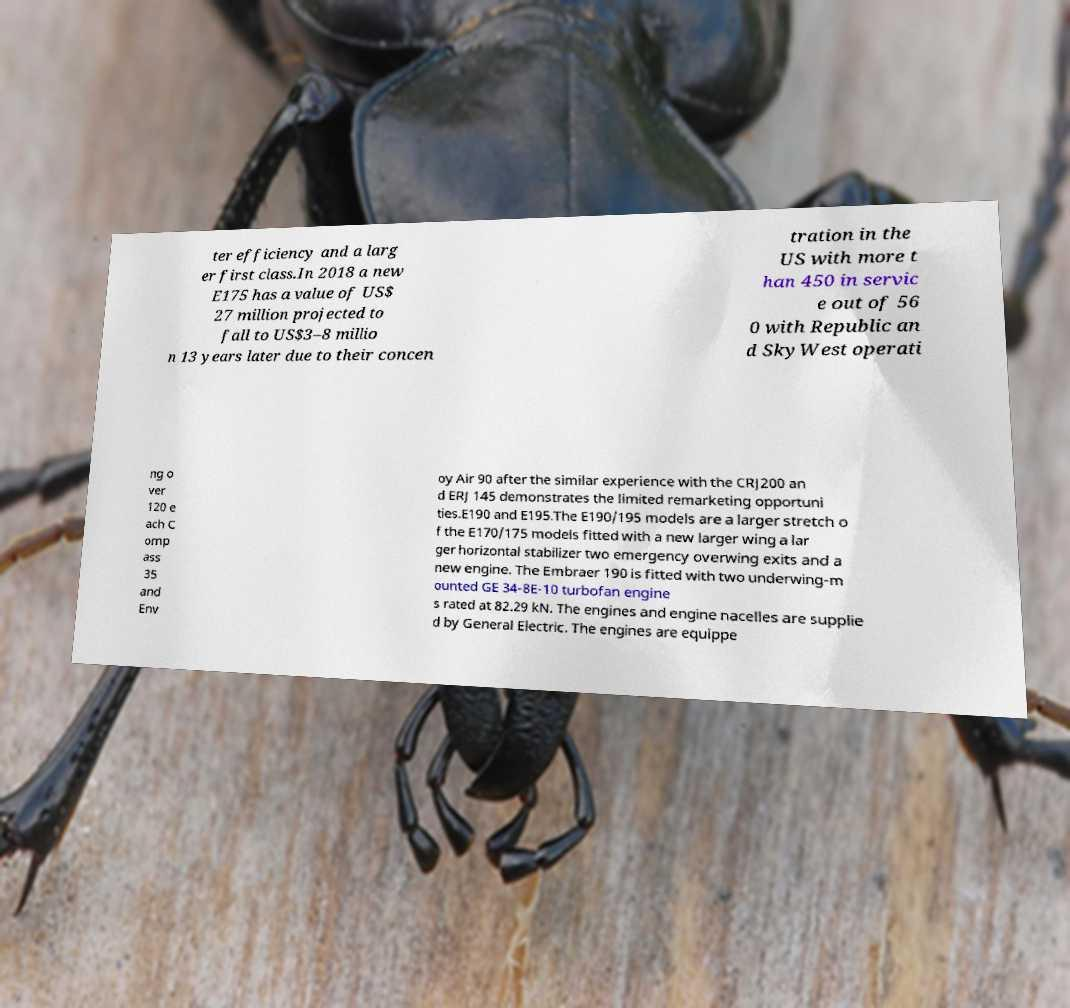Could you extract and type out the text from this image? ter efficiency and a larg er first class.In 2018 a new E175 has a value of US$ 27 million projected to fall to US$3–8 millio n 13 years later due to their concen tration in the US with more t han 450 in servic e out of 56 0 with Republic an d SkyWest operati ng o ver 120 e ach C omp ass 35 and Env oy Air 90 after the similar experience with the CRJ200 an d ERJ 145 demonstrates the limited remarketing opportuni ties.E190 and E195.The E190/195 models are a larger stretch o f the E170/175 models fitted with a new larger wing a lar ger horizontal stabilizer two emergency overwing exits and a new engine. The Embraer 190 is fitted with two underwing-m ounted GE 34-8E-10 turbofan engine s rated at 82.29 kN. The engines and engine nacelles are supplie d by General Electric. The engines are equippe 